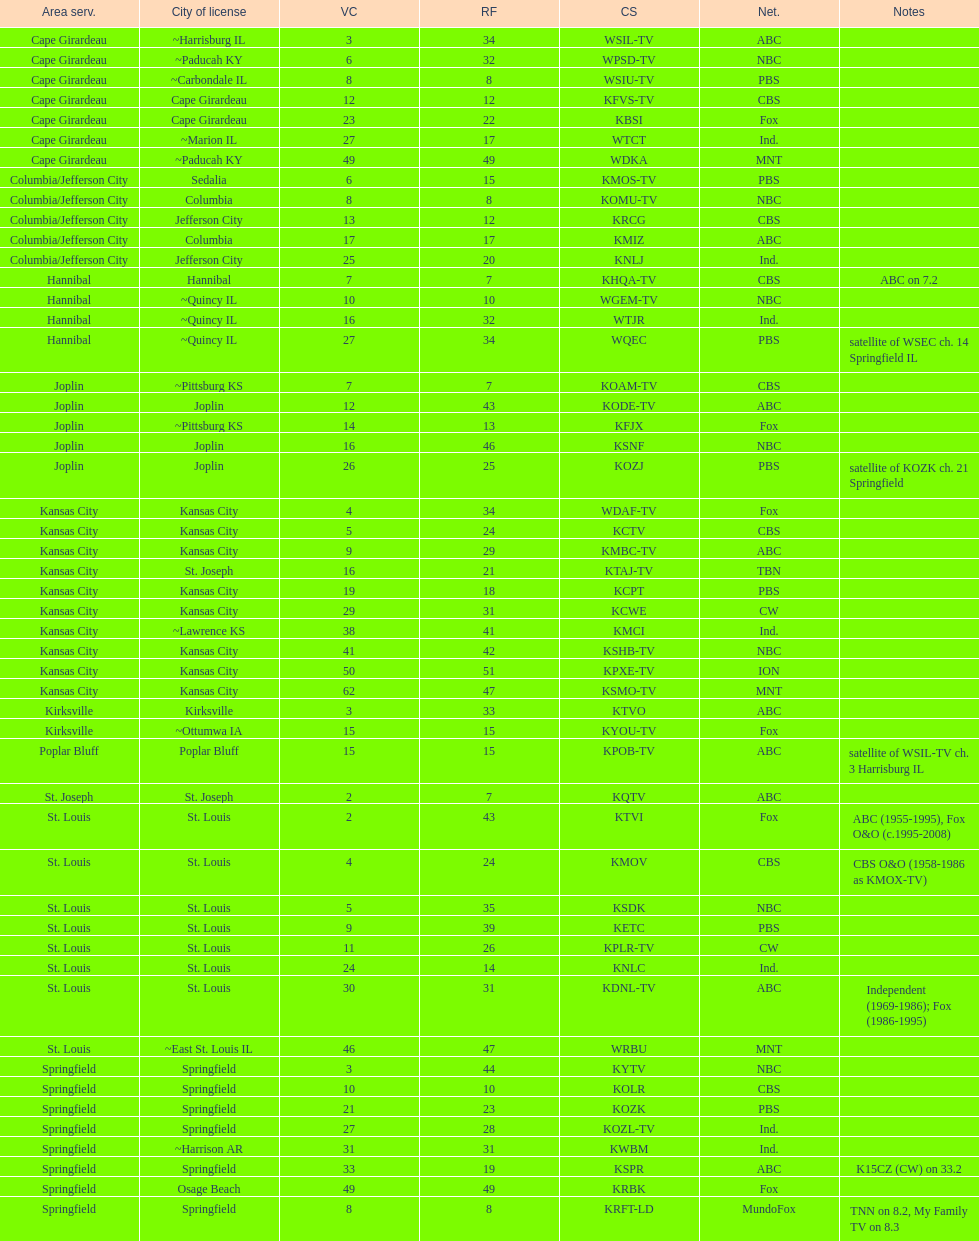How many areas have at least 5 stations? 6. 